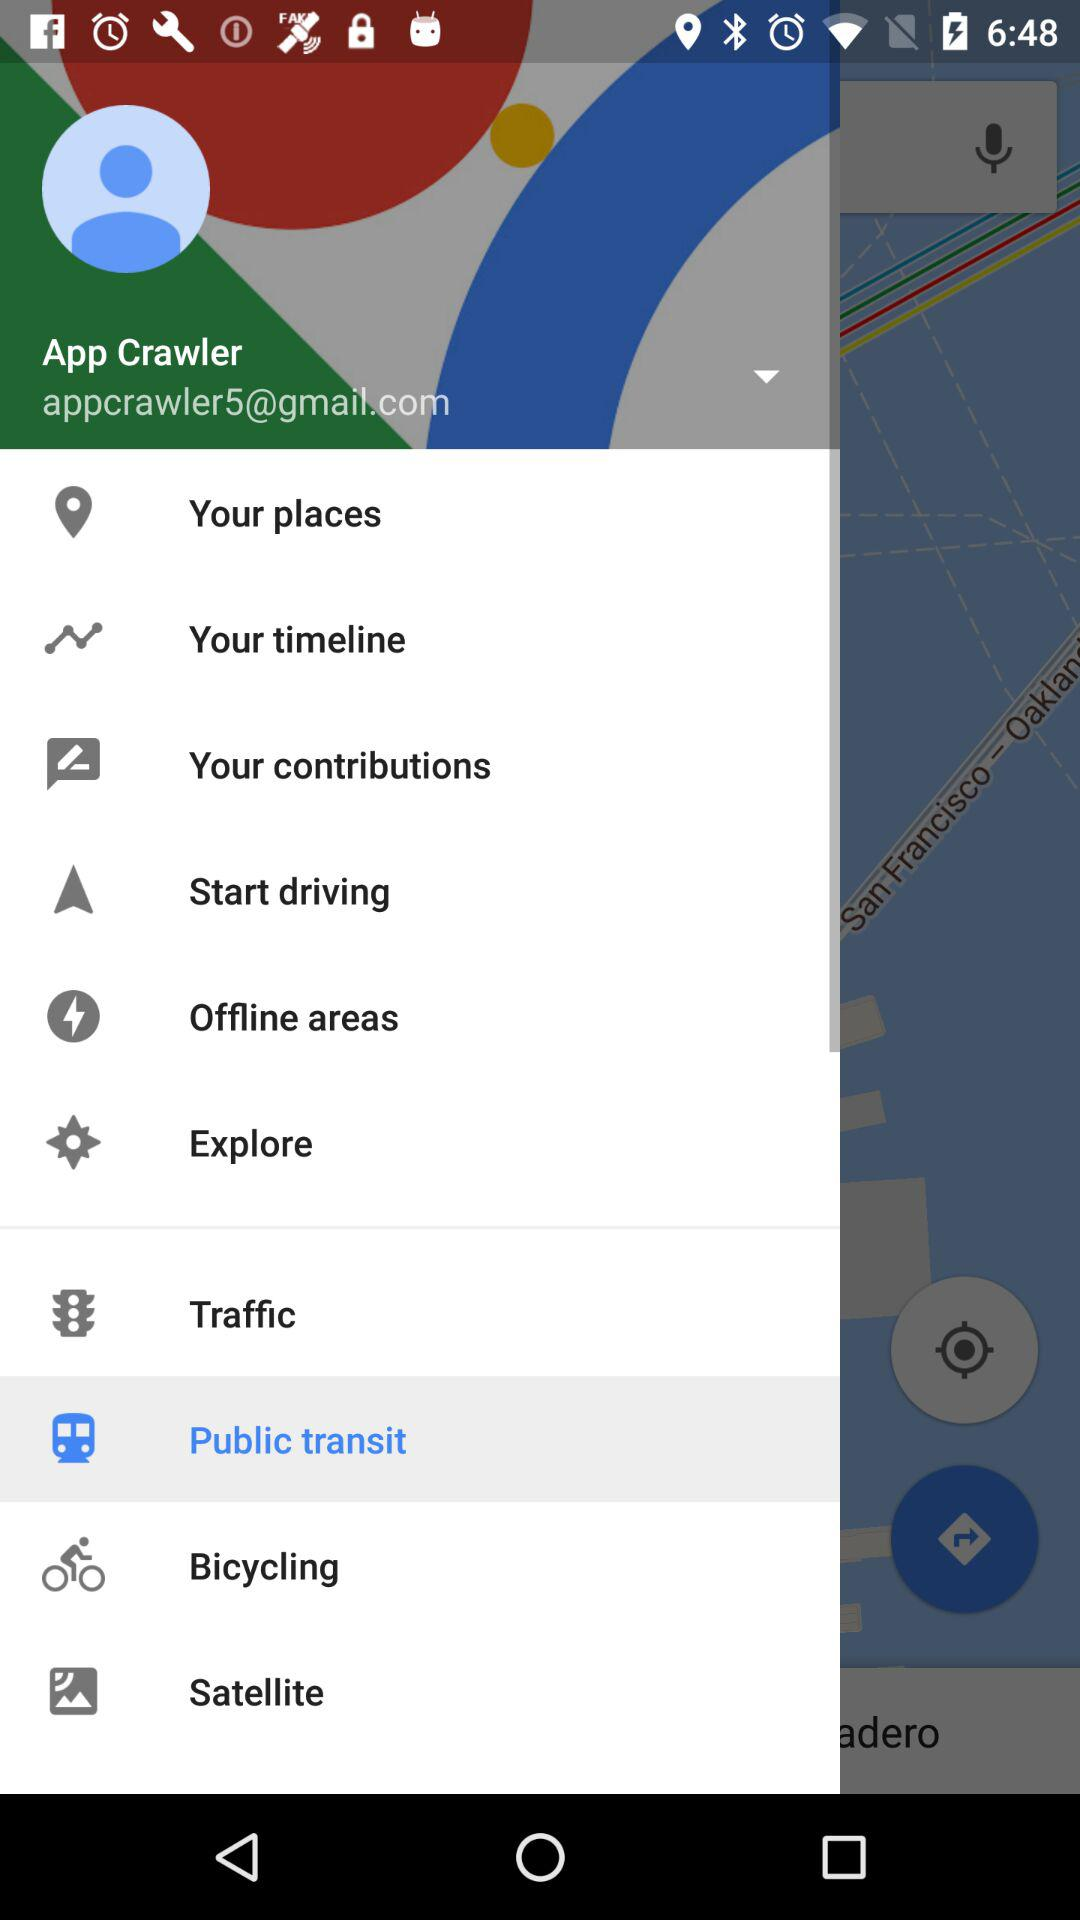What email address is used to log in? The email address used to log in is appcrawler5@gmail.com. 